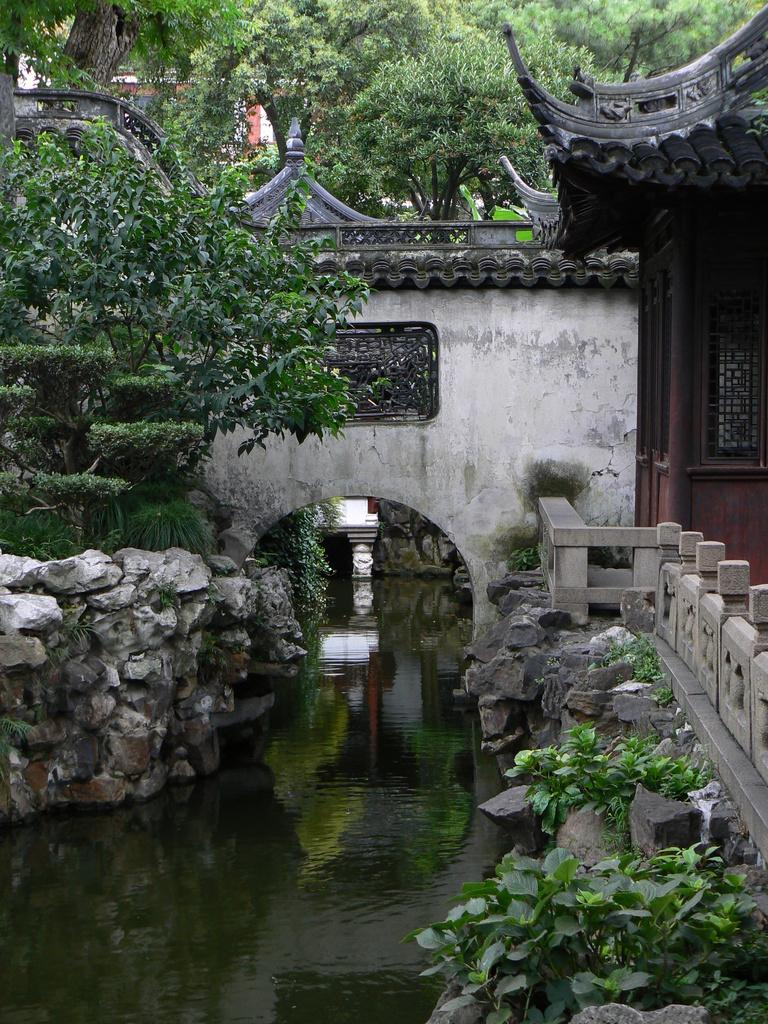What type of water feature is present in the image? There is a canal in the image. What can be seen on both sides of the canal? There are rocks on both sides of the canal. What structure is located on the right side of the image? There is a building on the right side of the image. What type of vegetation is visible in the backdrop of the image? There are plants and trees in the backdrop of the image. What type of brick is used to construct the vessel in the image? There is no vessel present in the image, and therefore no bricks to construct it. Is the person in the image sleeping? There is no person present in the image, so it is impossible to determine if anyone is sleeping. 